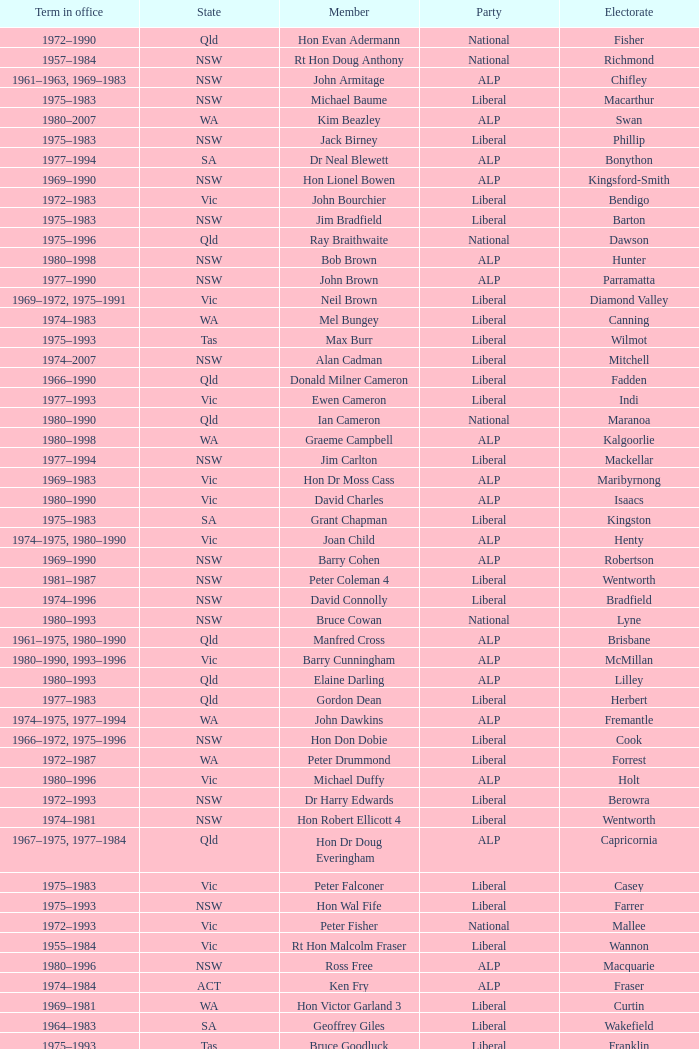Which party had a member from the state of Vic and an Electorate called Wannon? Liberal. Give me the full table as a dictionary. {'header': ['Term in office', 'State', 'Member', 'Party', 'Electorate'], 'rows': [['1972–1990', 'Qld', 'Hon Evan Adermann', 'National', 'Fisher'], ['1957–1984', 'NSW', 'Rt Hon Doug Anthony', 'National', 'Richmond'], ['1961–1963, 1969–1983', 'NSW', 'John Armitage', 'ALP', 'Chifley'], ['1975–1983', 'NSW', 'Michael Baume', 'Liberal', 'Macarthur'], ['1980–2007', 'WA', 'Kim Beazley', 'ALP', 'Swan'], ['1975–1983', 'NSW', 'Jack Birney', 'Liberal', 'Phillip'], ['1977–1994', 'SA', 'Dr Neal Blewett', 'ALP', 'Bonython'], ['1969–1990', 'NSW', 'Hon Lionel Bowen', 'ALP', 'Kingsford-Smith'], ['1972–1983', 'Vic', 'John Bourchier', 'Liberal', 'Bendigo'], ['1975–1983', 'NSW', 'Jim Bradfield', 'Liberal', 'Barton'], ['1975–1996', 'Qld', 'Ray Braithwaite', 'National', 'Dawson'], ['1980–1998', 'NSW', 'Bob Brown', 'ALP', 'Hunter'], ['1977–1990', 'NSW', 'John Brown', 'ALP', 'Parramatta'], ['1969–1972, 1975–1991', 'Vic', 'Neil Brown', 'Liberal', 'Diamond Valley'], ['1974–1983', 'WA', 'Mel Bungey', 'Liberal', 'Canning'], ['1975–1993', 'Tas', 'Max Burr', 'Liberal', 'Wilmot'], ['1974–2007', 'NSW', 'Alan Cadman', 'Liberal', 'Mitchell'], ['1966–1990', 'Qld', 'Donald Milner Cameron', 'Liberal', 'Fadden'], ['1977–1993', 'Vic', 'Ewen Cameron', 'Liberal', 'Indi'], ['1980–1990', 'Qld', 'Ian Cameron', 'National', 'Maranoa'], ['1980–1998', 'WA', 'Graeme Campbell', 'ALP', 'Kalgoorlie'], ['1977–1994', 'NSW', 'Jim Carlton', 'Liberal', 'Mackellar'], ['1969–1983', 'Vic', 'Hon Dr Moss Cass', 'ALP', 'Maribyrnong'], ['1980–1990', 'Vic', 'David Charles', 'ALP', 'Isaacs'], ['1975–1983', 'SA', 'Grant Chapman', 'Liberal', 'Kingston'], ['1974–1975, 1980–1990', 'Vic', 'Joan Child', 'ALP', 'Henty'], ['1969–1990', 'NSW', 'Barry Cohen', 'ALP', 'Robertson'], ['1981–1987', 'NSW', 'Peter Coleman 4', 'Liberal', 'Wentworth'], ['1974–1996', 'NSW', 'David Connolly', 'Liberal', 'Bradfield'], ['1980–1993', 'NSW', 'Bruce Cowan', 'National', 'Lyne'], ['1961–1975, 1980–1990', 'Qld', 'Manfred Cross', 'ALP', 'Brisbane'], ['1980–1990, 1993–1996', 'Vic', 'Barry Cunningham', 'ALP', 'McMillan'], ['1980–1993', 'Qld', 'Elaine Darling', 'ALP', 'Lilley'], ['1977–1983', 'Qld', 'Gordon Dean', 'Liberal', 'Herbert'], ['1974–1975, 1977–1994', 'WA', 'John Dawkins', 'ALP', 'Fremantle'], ['1966–1972, 1975–1996', 'NSW', 'Hon Don Dobie', 'Liberal', 'Cook'], ['1972–1987', 'WA', 'Peter Drummond', 'Liberal', 'Forrest'], ['1980–1996', 'Vic', 'Michael Duffy', 'ALP', 'Holt'], ['1972–1993', 'NSW', 'Dr Harry Edwards', 'Liberal', 'Berowra'], ['1974–1981', 'NSW', 'Hon Robert Ellicott 4', 'Liberal', 'Wentworth'], ['1967–1975, 1977–1984', 'Qld', 'Hon Dr Doug Everingham', 'ALP', 'Capricornia'], ['1975–1983', 'Vic', 'Peter Falconer', 'Liberal', 'Casey'], ['1975–1993', 'NSW', 'Hon Wal Fife', 'Liberal', 'Farrer'], ['1972–1993', 'Vic', 'Peter Fisher', 'National', 'Mallee'], ['1955–1984', 'Vic', 'Rt Hon Malcolm Fraser', 'Liberal', 'Wannon'], ['1980–1996', 'NSW', 'Ross Free', 'ALP', 'Macquarie'], ['1974–1984', 'ACT', 'Ken Fry', 'ALP', 'Fraser'], ['1969–1981', 'WA', 'Hon Victor Garland 3', 'Liberal', 'Curtin'], ['1964–1983', 'SA', 'Geoffrey Giles', 'Liberal', 'Wakefield'], ['1975–1993', 'Tas', 'Bruce Goodluck', 'Liberal', 'Franklin'], ['1975–1984', 'Tas', 'Hon Ray Groom', 'Liberal', 'Braddon'], ['1981–1996', 'SA', 'Steele Hall 2', 'Liberal', 'Boothby'], ['1980–1983', 'Vic', 'Graham Harris', 'Liberal', 'Chisholm'], ['1980–1992', 'Vic', 'Bob Hawke', 'ALP', 'Wills'], ['1961–1988', 'Qld', 'Hon Bill Hayden', 'ALP', 'Oxley'], ['1980–1998', 'NSW', 'Noel Hicks', 'National', 'Riverina'], ['1974–1983, 1984–1987', 'Qld', 'John Hodges', 'Liberal', 'Petrie'], ['1975–1987', 'Tas', 'Michael Hodgman', 'Liberal', 'Denison'], ['1977–1998', 'Vic', 'Clyde Holding', 'ALP', 'Melbourne Ports'], ['1974–2007', 'NSW', 'Hon John Howard', 'Liberal', 'Bennelong'], ['1977–1996', 'Vic', 'Brian Howe', 'ALP', 'Batman'], ['1977–1996', 'Qld', 'Ben Humphreys', 'ALP', 'Griffith'], ['1969–1989', 'NSW', 'Hon Ralph Hunt', 'National', 'Gwydir'], ['1969–1988', 'SA', 'Chris Hurford', 'ALP', 'Adelaide'], ['1974–1983', 'WA', 'John Hyde', 'Liberal', 'Moore'], ['1972–1983', 'Vic', 'Ted Innes', 'ALP', 'Melbourne'], ['1969–1987', 'SA', 'Ralph Jacobi', 'ALP', 'Hawker'], ['1966–1983', 'Vic', 'Alan Jarman', 'Liberal', 'Deakin'], ['1969–1985', 'Vic', 'Dr Harry Jenkins', 'ALP', 'Scullin'], ['1955–1966, 1969–1984', 'NSW', 'Hon Les Johnson', 'ALP', 'Hughes'], ['1977–1998', 'Vic', 'Barry Jones', 'ALP', 'Lalor'], ['1958–1983', 'NSW', 'Hon Charles Jones', 'ALP', 'Newcastle'], ['1975–1983, 1984–2007', 'Qld', 'David Jull', 'Liberal', 'Bowman'], ['1966–1990', 'Qld', 'Hon Bob Katter', 'National', 'Kennedy'], ['1969–1996', 'NSW', 'Hon Paul Keating', 'ALP', 'Blaxland'], ['1980–1995', 'ACT', 'Ros Kelly', 'ALP', 'Canberra'], ['1980–1990', 'Vic', 'Lewis Kent', 'ALP', 'Hotham'], ['1972–1975, 1978–1994', 'NSW', 'John Kerin', 'ALP', 'Werriwa'], ['1955–1983', 'Qld', 'Hon Jim Killen', 'Liberal', 'Moreton'], ['1969–1990', 'NSW', 'Dr Dick Klugman', 'ALP', 'Prospect'], ['1971–1996', 'Vic', 'Bruce Lloyd', 'National', 'Murray'], ['1974–1984', 'NSW', 'Stephen Lusher', 'National', 'Hume'], ['1966–1982', 'Vic', 'Rt Hon Phillip Lynch 6', 'Liberal', 'Flinders'], ['1969–1994', 'NSW', 'Hon Michael MacKellar', 'Liberal', 'Warringah'], ['1975–1983', 'NSW', 'Sandy Mackenzie', 'National', 'Calare'], ['1974–1990', 'Vic', 'Hon Ian Macphee', 'Liberal', 'Balaclava'], ['1982–1987', 'NSW', 'Michael Maher 5', 'ALP', 'Lowe'], ['1975–1983', 'WA', 'Ross McLean', 'Liberal', 'Perth'], ['1966–1981', 'SA', 'Hon John McLeay 2', 'Liberal', 'Boothby'], ['1979–2004', 'NSW', 'Leo McLeay', 'ALP', 'Grayndler'], ['1975–1983', 'NSW', 'Leslie McMahon', 'ALP', 'Sydney'], ['1949–1981', 'NSW', 'Rt Hon Sir William McMahon 5', 'Liberal', 'Lowe'], ['1972–1988', 'Qld', 'Tom McVeigh', 'National', 'Darling Downs'], ['1980–1990', 'Vic', 'John Mildren', 'ALP', 'Ballarat'], ['1974–1990', 'Qld', 'Clarrie Millar', 'National', 'Wide Bay'], ['1980–1990', 'Vic', 'Peter Milton', 'ALP', 'La Trobe'], ['1975–2001', 'Qld', 'John Moore', 'Liberal', 'Ryan'], ['1972–1998', 'NSW', 'Peter Morris', 'ALP', 'Shortland'], ['1969–1975, 1980–1984', 'NSW', 'Hon Bill Morrison', 'ALP', 'St George'], ['1980–1990', 'NSW', 'John Mountford', 'ALP', 'Banks'], ['1975–1984', 'Tas', 'Hon Kevin Newman', 'Liberal', 'Bass'], ['1961–1983', 'Vic', 'Hon Peter Nixon', 'National', 'Gippsland'], ['1969–1984', 'NSW', "Frank O'Keefe", 'National', 'Paterson'], ['1966–1994', 'Vic', 'Hon Andrew Peacock', 'Liberal', 'Kooyong'], ['1975–1990', 'SA', 'James Porter', 'Liberal', 'Barker'], ['1982–1983, 1984–2001', 'Vic', 'Peter Reith 6', 'Liberal', 'Flinders'], ['1972–1990', 'Qld', 'Hon Eric Robinson 1', 'Liberal', 'McPherson'], ['1963–1981', 'NSW', 'Hon Ian Robinson', 'National', 'Cowper'], ['1981–1998', 'WA', 'Allan Rocher 3', 'Liberal', 'Curtin'], ['1973–present', 'NSW', 'Philip Ruddock', 'Liberal', 'Dundas'], ['1975–1983', 'NSW', 'Murray Sainsbury', 'Liberal', 'Eden-Monaro'], ['1967–1993', 'Vic', 'Hon Gordon Scholes', 'ALP', 'Corio'], ['1980–1993', 'SA', 'John Scott', 'ALP', 'Hindmarsh'], ['1977–1983, 1984–1993', 'WA', 'Peter Shack', 'Liberal', 'Tangney'], ['1975–1990', 'Vic', 'Roger Shipton', 'Liberal', 'Higgins'], ['1963–1998', 'NSW', 'Rt Hon Ian Sinclair', 'National', 'New England'], ['1955–1983', 'Vic', 'Rt Hon Sir Billy Snedden', 'Liberal', 'Bruce'], ['1980–1990', 'NSW', 'John Spender', 'Liberal', 'North Sydney'], ['1966–1984', 'Vic', 'Hon Tony Street', 'Liberal', 'Corangamite'], ['1980–1983', 'NT', 'Grant Tambling', 'CLP', 'Northern Territory'], ['1980–2001', 'Vic', 'Dr Andrew Theophanous', 'ALP', 'Burke'], ['1975–1983', 'Qld', 'Hon David Thomson', 'National', 'Leichhardt'], ['1980–2010', 'WA', 'Wilson Tuckey', 'Liberal', "O'Connor"], ['1958–1990', 'NSW', 'Hon Tom Uren', 'ALP', 'Reid'], ['1972–1983', 'WA', 'Hon Ian Viner', 'Liberal', 'Stirling'], ['1969–1983', 'SA', 'Laurie Wallis', 'ALP', 'Grey'], ['1977–1993', 'NSW', 'Stewart West', 'ALP', 'Cunningham'], ['1981–1990', 'Qld', 'Peter White 1', 'Liberal', 'McPherson'], ['1972–1998', 'Vic', 'Ralph Willis', 'ALP', 'Gellibrand'], ['1966–1969, 1972–1993', 'SA', 'Ian Wilson', 'Liberal', 'Sturt'], ['1974–1988', 'SA', 'Mick Young', 'ALP', 'Port Adelaide']]} 